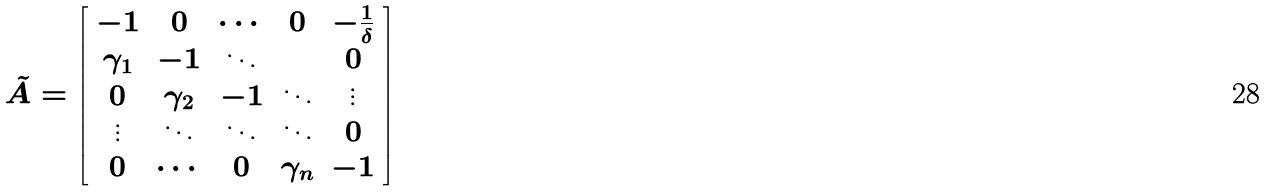<formula> <loc_0><loc_0><loc_500><loc_500>\tilde { A } = \left [ \begin{array} { c c c c c } - 1 & 0 & \cdots & 0 & - \frac { 1 } { \delta } \\ \gamma _ { 1 } & - 1 & \ddots & & 0 \\ 0 & \gamma _ { 2 } & - 1 & \ddots & \vdots \\ \vdots & \ddots & \ddots & \ddots & 0 \\ 0 & \cdots & 0 & \gamma _ { n } & - 1 \end{array} \right ]</formula> 